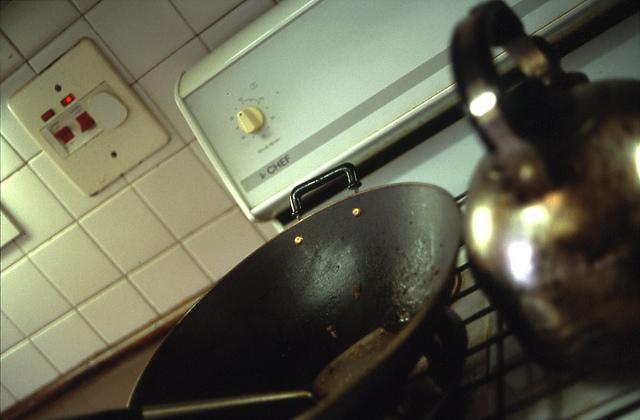Is the stove on?
Be succinct. No. What number of knobs are on this oven door?
Answer briefly. 1. Is there a tea kettle on the stove?
Write a very short answer. Yes. What is in the fry pan?
Keep it brief. Spatula. What is the fuel source being used to cook?
Answer briefly. Gas. 